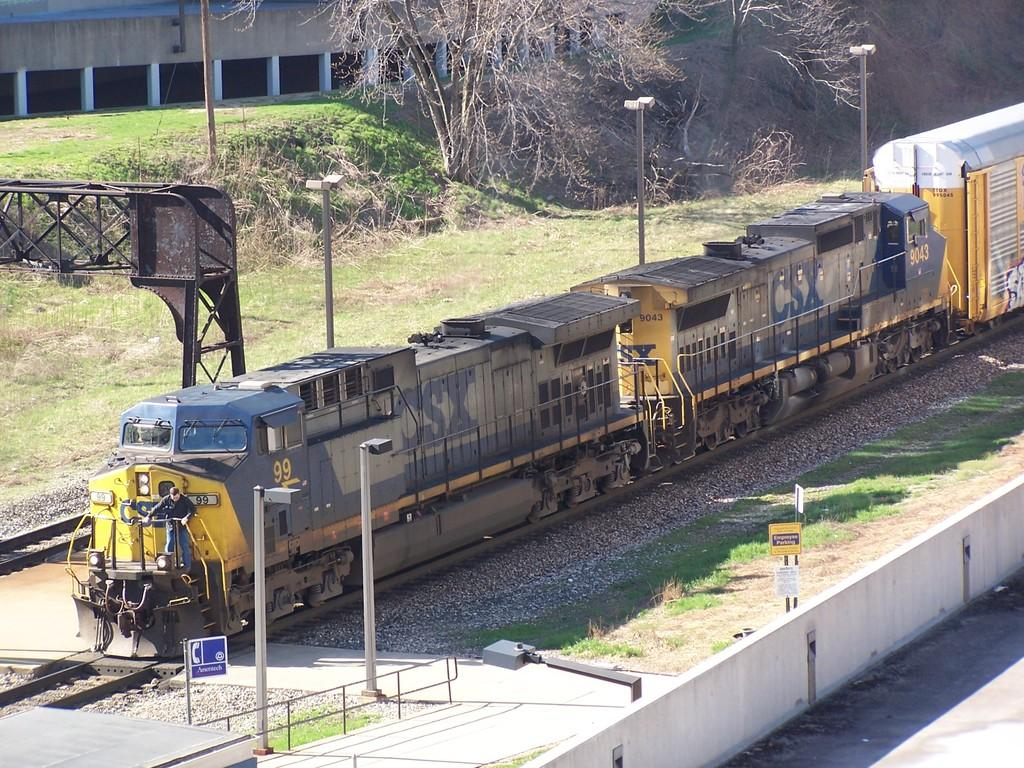What is the main subject of the image? The main subject of the image is a locomotive. What is the locomotive doing in the image? The locomotive is moving on a track in the image. What other objects can be seen in the image? There are poles, trees, and grass visible in the image. What is in the background of the image? There is a building in the background of the image. What type of paste is being used to guide the locomotive in the image? There is no paste or guiding mechanism visible in the image; the locomotive is simply moving on a track. 